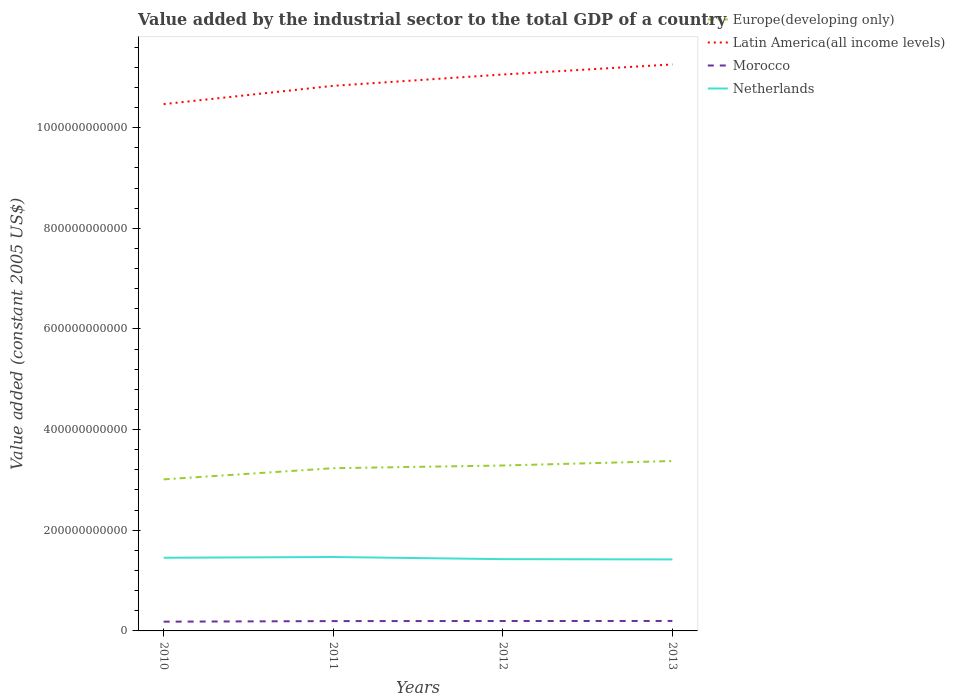How many different coloured lines are there?
Ensure brevity in your answer.  4. Across all years, what is the maximum value added by the industrial sector in Europe(developing only)?
Offer a terse response. 3.01e+11. In which year was the value added by the industrial sector in Morocco maximum?
Offer a very short reply. 2010. What is the total value added by the industrial sector in Europe(developing only) in the graph?
Give a very brief answer. -8.87e+09. What is the difference between the highest and the second highest value added by the industrial sector in Europe(developing only)?
Ensure brevity in your answer.  3.64e+1. Is the value added by the industrial sector in Latin America(all income levels) strictly greater than the value added by the industrial sector in Morocco over the years?
Your answer should be compact. No. What is the difference between two consecutive major ticks on the Y-axis?
Your response must be concise. 2.00e+11. Does the graph contain any zero values?
Offer a very short reply. No. What is the title of the graph?
Your response must be concise. Value added by the industrial sector to the total GDP of a country. What is the label or title of the Y-axis?
Make the answer very short. Value added (constant 2005 US$). What is the Value added (constant 2005 US$) of Europe(developing only) in 2010?
Keep it short and to the point. 3.01e+11. What is the Value added (constant 2005 US$) of Latin America(all income levels) in 2010?
Make the answer very short. 1.05e+12. What is the Value added (constant 2005 US$) of Morocco in 2010?
Keep it short and to the point. 1.84e+1. What is the Value added (constant 2005 US$) of Netherlands in 2010?
Your response must be concise. 1.45e+11. What is the Value added (constant 2005 US$) in Europe(developing only) in 2011?
Give a very brief answer. 3.23e+11. What is the Value added (constant 2005 US$) in Latin America(all income levels) in 2011?
Provide a succinct answer. 1.08e+12. What is the Value added (constant 2005 US$) in Morocco in 2011?
Make the answer very short. 1.95e+1. What is the Value added (constant 2005 US$) of Netherlands in 2011?
Offer a terse response. 1.47e+11. What is the Value added (constant 2005 US$) of Europe(developing only) in 2012?
Your answer should be compact. 3.29e+11. What is the Value added (constant 2005 US$) of Latin America(all income levels) in 2012?
Offer a very short reply. 1.11e+12. What is the Value added (constant 2005 US$) in Morocco in 2012?
Give a very brief answer. 1.97e+1. What is the Value added (constant 2005 US$) in Netherlands in 2012?
Give a very brief answer. 1.43e+11. What is the Value added (constant 2005 US$) in Europe(developing only) in 2013?
Offer a terse response. 3.38e+11. What is the Value added (constant 2005 US$) of Latin America(all income levels) in 2013?
Keep it short and to the point. 1.13e+12. What is the Value added (constant 2005 US$) of Morocco in 2013?
Provide a short and direct response. 1.98e+1. What is the Value added (constant 2005 US$) in Netherlands in 2013?
Make the answer very short. 1.42e+11. Across all years, what is the maximum Value added (constant 2005 US$) of Europe(developing only)?
Give a very brief answer. 3.38e+11. Across all years, what is the maximum Value added (constant 2005 US$) in Latin America(all income levels)?
Offer a terse response. 1.13e+12. Across all years, what is the maximum Value added (constant 2005 US$) in Morocco?
Offer a terse response. 1.98e+1. Across all years, what is the maximum Value added (constant 2005 US$) in Netherlands?
Offer a terse response. 1.47e+11. Across all years, what is the minimum Value added (constant 2005 US$) of Europe(developing only)?
Offer a terse response. 3.01e+11. Across all years, what is the minimum Value added (constant 2005 US$) of Latin America(all income levels)?
Give a very brief answer. 1.05e+12. Across all years, what is the minimum Value added (constant 2005 US$) in Morocco?
Your answer should be very brief. 1.84e+1. Across all years, what is the minimum Value added (constant 2005 US$) of Netherlands?
Give a very brief answer. 1.42e+11. What is the total Value added (constant 2005 US$) of Europe(developing only) in the graph?
Make the answer very short. 1.29e+12. What is the total Value added (constant 2005 US$) in Latin America(all income levels) in the graph?
Your answer should be compact. 4.36e+12. What is the total Value added (constant 2005 US$) of Morocco in the graph?
Offer a terse response. 7.74e+1. What is the total Value added (constant 2005 US$) in Netherlands in the graph?
Offer a very short reply. 5.77e+11. What is the difference between the Value added (constant 2005 US$) of Europe(developing only) in 2010 and that in 2011?
Give a very brief answer. -2.22e+1. What is the difference between the Value added (constant 2005 US$) in Latin America(all income levels) in 2010 and that in 2011?
Your response must be concise. -3.64e+1. What is the difference between the Value added (constant 2005 US$) in Morocco in 2010 and that in 2011?
Provide a succinct answer. -1.16e+09. What is the difference between the Value added (constant 2005 US$) of Netherlands in 2010 and that in 2011?
Keep it short and to the point. -1.48e+09. What is the difference between the Value added (constant 2005 US$) in Europe(developing only) in 2010 and that in 2012?
Your answer should be very brief. -2.75e+1. What is the difference between the Value added (constant 2005 US$) of Latin America(all income levels) in 2010 and that in 2012?
Provide a short and direct response. -5.89e+1. What is the difference between the Value added (constant 2005 US$) in Morocco in 2010 and that in 2012?
Make the answer very short. -1.31e+09. What is the difference between the Value added (constant 2005 US$) in Netherlands in 2010 and that in 2012?
Offer a terse response. 2.77e+09. What is the difference between the Value added (constant 2005 US$) of Europe(developing only) in 2010 and that in 2013?
Give a very brief answer. -3.64e+1. What is the difference between the Value added (constant 2005 US$) in Latin America(all income levels) in 2010 and that in 2013?
Your answer should be compact. -7.89e+1. What is the difference between the Value added (constant 2005 US$) of Morocco in 2010 and that in 2013?
Offer a terse response. -1.42e+09. What is the difference between the Value added (constant 2005 US$) in Netherlands in 2010 and that in 2013?
Your answer should be very brief. 3.32e+09. What is the difference between the Value added (constant 2005 US$) of Europe(developing only) in 2011 and that in 2012?
Make the answer very short. -5.36e+09. What is the difference between the Value added (constant 2005 US$) of Latin America(all income levels) in 2011 and that in 2012?
Give a very brief answer. -2.25e+1. What is the difference between the Value added (constant 2005 US$) in Morocco in 2011 and that in 2012?
Provide a succinct answer. -1.49e+08. What is the difference between the Value added (constant 2005 US$) of Netherlands in 2011 and that in 2012?
Your response must be concise. 4.24e+09. What is the difference between the Value added (constant 2005 US$) in Europe(developing only) in 2011 and that in 2013?
Provide a succinct answer. -1.42e+1. What is the difference between the Value added (constant 2005 US$) in Latin America(all income levels) in 2011 and that in 2013?
Your answer should be very brief. -4.25e+1. What is the difference between the Value added (constant 2005 US$) in Morocco in 2011 and that in 2013?
Provide a succinct answer. -2.65e+08. What is the difference between the Value added (constant 2005 US$) of Netherlands in 2011 and that in 2013?
Offer a terse response. 4.80e+09. What is the difference between the Value added (constant 2005 US$) in Europe(developing only) in 2012 and that in 2013?
Ensure brevity in your answer.  -8.87e+09. What is the difference between the Value added (constant 2005 US$) of Latin America(all income levels) in 2012 and that in 2013?
Provide a short and direct response. -2.00e+1. What is the difference between the Value added (constant 2005 US$) in Morocco in 2012 and that in 2013?
Your answer should be compact. -1.16e+08. What is the difference between the Value added (constant 2005 US$) in Netherlands in 2012 and that in 2013?
Ensure brevity in your answer.  5.54e+08. What is the difference between the Value added (constant 2005 US$) of Europe(developing only) in 2010 and the Value added (constant 2005 US$) of Latin America(all income levels) in 2011?
Offer a very short reply. -7.82e+11. What is the difference between the Value added (constant 2005 US$) of Europe(developing only) in 2010 and the Value added (constant 2005 US$) of Morocco in 2011?
Ensure brevity in your answer.  2.82e+11. What is the difference between the Value added (constant 2005 US$) in Europe(developing only) in 2010 and the Value added (constant 2005 US$) in Netherlands in 2011?
Offer a very short reply. 1.54e+11. What is the difference between the Value added (constant 2005 US$) of Latin America(all income levels) in 2010 and the Value added (constant 2005 US$) of Morocco in 2011?
Provide a succinct answer. 1.03e+12. What is the difference between the Value added (constant 2005 US$) of Latin America(all income levels) in 2010 and the Value added (constant 2005 US$) of Netherlands in 2011?
Your response must be concise. 9.00e+11. What is the difference between the Value added (constant 2005 US$) of Morocco in 2010 and the Value added (constant 2005 US$) of Netherlands in 2011?
Your answer should be compact. -1.29e+11. What is the difference between the Value added (constant 2005 US$) of Europe(developing only) in 2010 and the Value added (constant 2005 US$) of Latin America(all income levels) in 2012?
Your answer should be compact. -8.04e+11. What is the difference between the Value added (constant 2005 US$) in Europe(developing only) in 2010 and the Value added (constant 2005 US$) in Morocco in 2012?
Your answer should be compact. 2.81e+11. What is the difference between the Value added (constant 2005 US$) in Europe(developing only) in 2010 and the Value added (constant 2005 US$) in Netherlands in 2012?
Offer a very short reply. 1.59e+11. What is the difference between the Value added (constant 2005 US$) of Latin America(all income levels) in 2010 and the Value added (constant 2005 US$) of Morocco in 2012?
Your answer should be very brief. 1.03e+12. What is the difference between the Value added (constant 2005 US$) of Latin America(all income levels) in 2010 and the Value added (constant 2005 US$) of Netherlands in 2012?
Provide a succinct answer. 9.04e+11. What is the difference between the Value added (constant 2005 US$) of Morocco in 2010 and the Value added (constant 2005 US$) of Netherlands in 2012?
Keep it short and to the point. -1.24e+11. What is the difference between the Value added (constant 2005 US$) in Europe(developing only) in 2010 and the Value added (constant 2005 US$) in Latin America(all income levels) in 2013?
Give a very brief answer. -8.24e+11. What is the difference between the Value added (constant 2005 US$) of Europe(developing only) in 2010 and the Value added (constant 2005 US$) of Morocco in 2013?
Your answer should be compact. 2.81e+11. What is the difference between the Value added (constant 2005 US$) in Europe(developing only) in 2010 and the Value added (constant 2005 US$) in Netherlands in 2013?
Offer a very short reply. 1.59e+11. What is the difference between the Value added (constant 2005 US$) in Latin America(all income levels) in 2010 and the Value added (constant 2005 US$) in Morocco in 2013?
Provide a short and direct response. 1.03e+12. What is the difference between the Value added (constant 2005 US$) of Latin America(all income levels) in 2010 and the Value added (constant 2005 US$) of Netherlands in 2013?
Your answer should be very brief. 9.05e+11. What is the difference between the Value added (constant 2005 US$) of Morocco in 2010 and the Value added (constant 2005 US$) of Netherlands in 2013?
Keep it short and to the point. -1.24e+11. What is the difference between the Value added (constant 2005 US$) in Europe(developing only) in 2011 and the Value added (constant 2005 US$) in Latin America(all income levels) in 2012?
Your response must be concise. -7.82e+11. What is the difference between the Value added (constant 2005 US$) in Europe(developing only) in 2011 and the Value added (constant 2005 US$) in Morocco in 2012?
Your response must be concise. 3.04e+11. What is the difference between the Value added (constant 2005 US$) in Europe(developing only) in 2011 and the Value added (constant 2005 US$) in Netherlands in 2012?
Offer a very short reply. 1.81e+11. What is the difference between the Value added (constant 2005 US$) in Latin America(all income levels) in 2011 and the Value added (constant 2005 US$) in Morocco in 2012?
Offer a terse response. 1.06e+12. What is the difference between the Value added (constant 2005 US$) in Latin America(all income levels) in 2011 and the Value added (constant 2005 US$) in Netherlands in 2012?
Give a very brief answer. 9.40e+11. What is the difference between the Value added (constant 2005 US$) of Morocco in 2011 and the Value added (constant 2005 US$) of Netherlands in 2012?
Offer a terse response. -1.23e+11. What is the difference between the Value added (constant 2005 US$) of Europe(developing only) in 2011 and the Value added (constant 2005 US$) of Latin America(all income levels) in 2013?
Give a very brief answer. -8.02e+11. What is the difference between the Value added (constant 2005 US$) in Europe(developing only) in 2011 and the Value added (constant 2005 US$) in Morocco in 2013?
Keep it short and to the point. 3.04e+11. What is the difference between the Value added (constant 2005 US$) of Europe(developing only) in 2011 and the Value added (constant 2005 US$) of Netherlands in 2013?
Your answer should be compact. 1.81e+11. What is the difference between the Value added (constant 2005 US$) of Latin America(all income levels) in 2011 and the Value added (constant 2005 US$) of Morocco in 2013?
Provide a succinct answer. 1.06e+12. What is the difference between the Value added (constant 2005 US$) in Latin America(all income levels) in 2011 and the Value added (constant 2005 US$) in Netherlands in 2013?
Provide a succinct answer. 9.41e+11. What is the difference between the Value added (constant 2005 US$) in Morocco in 2011 and the Value added (constant 2005 US$) in Netherlands in 2013?
Offer a very short reply. -1.23e+11. What is the difference between the Value added (constant 2005 US$) in Europe(developing only) in 2012 and the Value added (constant 2005 US$) in Latin America(all income levels) in 2013?
Your answer should be compact. -7.97e+11. What is the difference between the Value added (constant 2005 US$) in Europe(developing only) in 2012 and the Value added (constant 2005 US$) in Morocco in 2013?
Your answer should be compact. 3.09e+11. What is the difference between the Value added (constant 2005 US$) of Europe(developing only) in 2012 and the Value added (constant 2005 US$) of Netherlands in 2013?
Offer a terse response. 1.87e+11. What is the difference between the Value added (constant 2005 US$) in Latin America(all income levels) in 2012 and the Value added (constant 2005 US$) in Morocco in 2013?
Your answer should be very brief. 1.09e+12. What is the difference between the Value added (constant 2005 US$) in Latin America(all income levels) in 2012 and the Value added (constant 2005 US$) in Netherlands in 2013?
Provide a short and direct response. 9.63e+11. What is the difference between the Value added (constant 2005 US$) in Morocco in 2012 and the Value added (constant 2005 US$) in Netherlands in 2013?
Ensure brevity in your answer.  -1.22e+11. What is the average Value added (constant 2005 US$) in Europe(developing only) per year?
Make the answer very short. 3.23e+11. What is the average Value added (constant 2005 US$) in Latin America(all income levels) per year?
Your answer should be very brief. 1.09e+12. What is the average Value added (constant 2005 US$) of Morocco per year?
Make the answer very short. 1.93e+1. What is the average Value added (constant 2005 US$) in Netherlands per year?
Make the answer very short. 1.44e+11. In the year 2010, what is the difference between the Value added (constant 2005 US$) in Europe(developing only) and Value added (constant 2005 US$) in Latin America(all income levels)?
Your answer should be very brief. -7.46e+11. In the year 2010, what is the difference between the Value added (constant 2005 US$) in Europe(developing only) and Value added (constant 2005 US$) in Morocco?
Provide a succinct answer. 2.83e+11. In the year 2010, what is the difference between the Value added (constant 2005 US$) of Europe(developing only) and Value added (constant 2005 US$) of Netherlands?
Offer a terse response. 1.56e+11. In the year 2010, what is the difference between the Value added (constant 2005 US$) of Latin America(all income levels) and Value added (constant 2005 US$) of Morocco?
Your answer should be very brief. 1.03e+12. In the year 2010, what is the difference between the Value added (constant 2005 US$) in Latin America(all income levels) and Value added (constant 2005 US$) in Netherlands?
Make the answer very short. 9.01e+11. In the year 2010, what is the difference between the Value added (constant 2005 US$) in Morocco and Value added (constant 2005 US$) in Netherlands?
Give a very brief answer. -1.27e+11. In the year 2011, what is the difference between the Value added (constant 2005 US$) in Europe(developing only) and Value added (constant 2005 US$) in Latin America(all income levels)?
Your answer should be compact. -7.60e+11. In the year 2011, what is the difference between the Value added (constant 2005 US$) in Europe(developing only) and Value added (constant 2005 US$) in Morocco?
Offer a very short reply. 3.04e+11. In the year 2011, what is the difference between the Value added (constant 2005 US$) of Europe(developing only) and Value added (constant 2005 US$) of Netherlands?
Ensure brevity in your answer.  1.76e+11. In the year 2011, what is the difference between the Value added (constant 2005 US$) in Latin America(all income levels) and Value added (constant 2005 US$) in Morocco?
Offer a terse response. 1.06e+12. In the year 2011, what is the difference between the Value added (constant 2005 US$) in Latin America(all income levels) and Value added (constant 2005 US$) in Netherlands?
Keep it short and to the point. 9.36e+11. In the year 2011, what is the difference between the Value added (constant 2005 US$) in Morocco and Value added (constant 2005 US$) in Netherlands?
Ensure brevity in your answer.  -1.27e+11. In the year 2012, what is the difference between the Value added (constant 2005 US$) in Europe(developing only) and Value added (constant 2005 US$) in Latin America(all income levels)?
Give a very brief answer. -7.77e+11. In the year 2012, what is the difference between the Value added (constant 2005 US$) in Europe(developing only) and Value added (constant 2005 US$) in Morocco?
Keep it short and to the point. 3.09e+11. In the year 2012, what is the difference between the Value added (constant 2005 US$) of Europe(developing only) and Value added (constant 2005 US$) of Netherlands?
Your response must be concise. 1.86e+11. In the year 2012, what is the difference between the Value added (constant 2005 US$) in Latin America(all income levels) and Value added (constant 2005 US$) in Morocco?
Offer a terse response. 1.09e+12. In the year 2012, what is the difference between the Value added (constant 2005 US$) of Latin America(all income levels) and Value added (constant 2005 US$) of Netherlands?
Provide a succinct answer. 9.63e+11. In the year 2012, what is the difference between the Value added (constant 2005 US$) in Morocco and Value added (constant 2005 US$) in Netherlands?
Give a very brief answer. -1.23e+11. In the year 2013, what is the difference between the Value added (constant 2005 US$) of Europe(developing only) and Value added (constant 2005 US$) of Latin America(all income levels)?
Keep it short and to the point. -7.88e+11. In the year 2013, what is the difference between the Value added (constant 2005 US$) in Europe(developing only) and Value added (constant 2005 US$) in Morocco?
Offer a very short reply. 3.18e+11. In the year 2013, what is the difference between the Value added (constant 2005 US$) in Europe(developing only) and Value added (constant 2005 US$) in Netherlands?
Make the answer very short. 1.95e+11. In the year 2013, what is the difference between the Value added (constant 2005 US$) in Latin America(all income levels) and Value added (constant 2005 US$) in Morocco?
Your answer should be very brief. 1.11e+12. In the year 2013, what is the difference between the Value added (constant 2005 US$) in Latin America(all income levels) and Value added (constant 2005 US$) in Netherlands?
Provide a short and direct response. 9.83e+11. In the year 2013, what is the difference between the Value added (constant 2005 US$) in Morocco and Value added (constant 2005 US$) in Netherlands?
Ensure brevity in your answer.  -1.22e+11. What is the ratio of the Value added (constant 2005 US$) in Europe(developing only) in 2010 to that in 2011?
Keep it short and to the point. 0.93. What is the ratio of the Value added (constant 2005 US$) in Latin America(all income levels) in 2010 to that in 2011?
Give a very brief answer. 0.97. What is the ratio of the Value added (constant 2005 US$) of Morocco in 2010 to that in 2011?
Your answer should be very brief. 0.94. What is the ratio of the Value added (constant 2005 US$) in Netherlands in 2010 to that in 2011?
Ensure brevity in your answer.  0.99. What is the ratio of the Value added (constant 2005 US$) of Europe(developing only) in 2010 to that in 2012?
Your answer should be very brief. 0.92. What is the ratio of the Value added (constant 2005 US$) of Latin America(all income levels) in 2010 to that in 2012?
Provide a succinct answer. 0.95. What is the ratio of the Value added (constant 2005 US$) in Morocco in 2010 to that in 2012?
Ensure brevity in your answer.  0.93. What is the ratio of the Value added (constant 2005 US$) in Netherlands in 2010 to that in 2012?
Your answer should be very brief. 1.02. What is the ratio of the Value added (constant 2005 US$) in Europe(developing only) in 2010 to that in 2013?
Your answer should be compact. 0.89. What is the ratio of the Value added (constant 2005 US$) of Latin America(all income levels) in 2010 to that in 2013?
Make the answer very short. 0.93. What is the ratio of the Value added (constant 2005 US$) of Morocco in 2010 to that in 2013?
Keep it short and to the point. 0.93. What is the ratio of the Value added (constant 2005 US$) of Netherlands in 2010 to that in 2013?
Give a very brief answer. 1.02. What is the ratio of the Value added (constant 2005 US$) of Europe(developing only) in 2011 to that in 2012?
Keep it short and to the point. 0.98. What is the ratio of the Value added (constant 2005 US$) in Latin America(all income levels) in 2011 to that in 2012?
Your response must be concise. 0.98. What is the ratio of the Value added (constant 2005 US$) in Morocco in 2011 to that in 2012?
Ensure brevity in your answer.  0.99. What is the ratio of the Value added (constant 2005 US$) in Netherlands in 2011 to that in 2012?
Your answer should be compact. 1.03. What is the ratio of the Value added (constant 2005 US$) in Europe(developing only) in 2011 to that in 2013?
Provide a short and direct response. 0.96. What is the ratio of the Value added (constant 2005 US$) in Latin America(all income levels) in 2011 to that in 2013?
Make the answer very short. 0.96. What is the ratio of the Value added (constant 2005 US$) of Morocco in 2011 to that in 2013?
Your response must be concise. 0.99. What is the ratio of the Value added (constant 2005 US$) of Netherlands in 2011 to that in 2013?
Your response must be concise. 1.03. What is the ratio of the Value added (constant 2005 US$) in Europe(developing only) in 2012 to that in 2013?
Offer a very short reply. 0.97. What is the ratio of the Value added (constant 2005 US$) in Latin America(all income levels) in 2012 to that in 2013?
Your answer should be compact. 0.98. What is the ratio of the Value added (constant 2005 US$) in Morocco in 2012 to that in 2013?
Provide a succinct answer. 0.99. What is the ratio of the Value added (constant 2005 US$) of Netherlands in 2012 to that in 2013?
Offer a very short reply. 1. What is the difference between the highest and the second highest Value added (constant 2005 US$) of Europe(developing only)?
Offer a terse response. 8.87e+09. What is the difference between the highest and the second highest Value added (constant 2005 US$) in Latin America(all income levels)?
Ensure brevity in your answer.  2.00e+1. What is the difference between the highest and the second highest Value added (constant 2005 US$) in Morocco?
Offer a very short reply. 1.16e+08. What is the difference between the highest and the second highest Value added (constant 2005 US$) of Netherlands?
Provide a short and direct response. 1.48e+09. What is the difference between the highest and the lowest Value added (constant 2005 US$) of Europe(developing only)?
Your response must be concise. 3.64e+1. What is the difference between the highest and the lowest Value added (constant 2005 US$) of Latin America(all income levels)?
Offer a very short reply. 7.89e+1. What is the difference between the highest and the lowest Value added (constant 2005 US$) of Morocco?
Offer a very short reply. 1.42e+09. What is the difference between the highest and the lowest Value added (constant 2005 US$) in Netherlands?
Offer a very short reply. 4.80e+09. 